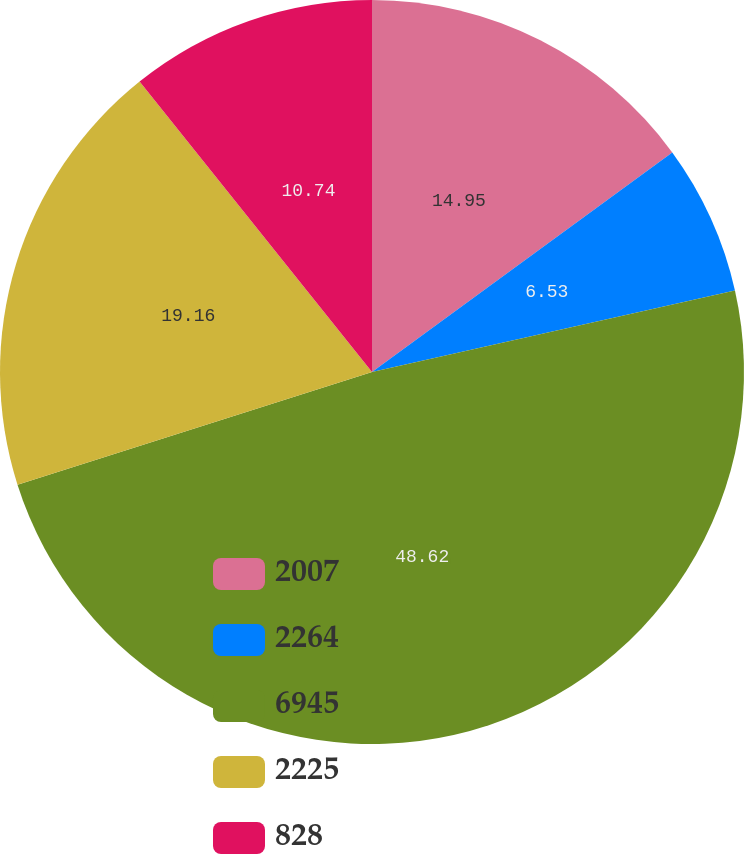Convert chart to OTSL. <chart><loc_0><loc_0><loc_500><loc_500><pie_chart><fcel>2007<fcel>2264<fcel>6945<fcel>2225<fcel>828<nl><fcel>14.95%<fcel>6.53%<fcel>48.62%<fcel>19.16%<fcel>10.74%<nl></chart> 